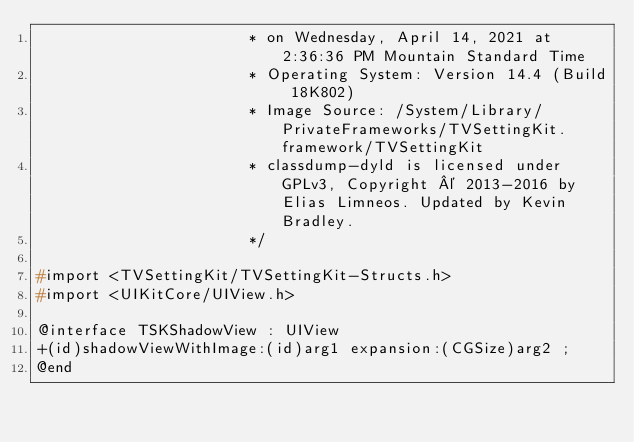<code> <loc_0><loc_0><loc_500><loc_500><_C_>                       * on Wednesday, April 14, 2021 at 2:36:36 PM Mountain Standard Time
                       * Operating System: Version 14.4 (Build 18K802)
                       * Image Source: /System/Library/PrivateFrameworks/TVSettingKit.framework/TVSettingKit
                       * classdump-dyld is licensed under GPLv3, Copyright © 2013-2016 by Elias Limneos. Updated by Kevin Bradley.
                       */

#import <TVSettingKit/TVSettingKit-Structs.h>
#import <UIKitCore/UIView.h>

@interface TSKShadowView : UIView
+(id)shadowViewWithImage:(id)arg1 expansion:(CGSize)arg2 ;
@end

</code> 